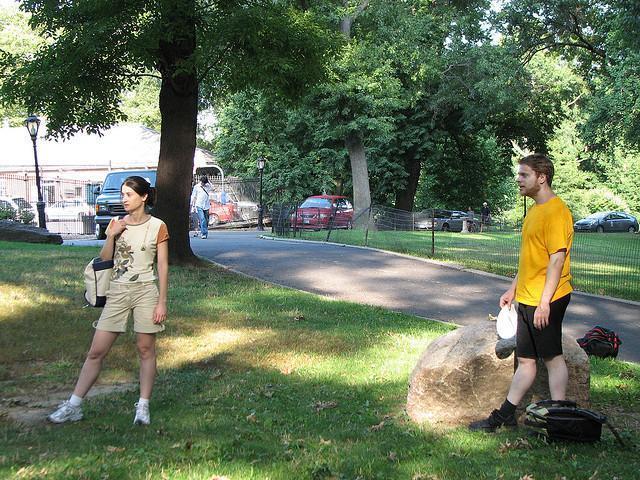How many backpacks are visible?
Give a very brief answer. 1. How many people are in the photo?
Give a very brief answer. 2. 